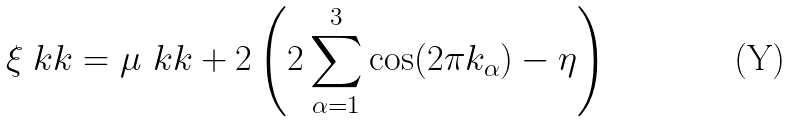Convert formula to latex. <formula><loc_0><loc_0><loc_500><loc_500>\xi _ { \ } k k = \mu _ { \ } k k + 2 \left ( 2 \sum _ { \alpha = 1 } ^ { 3 } \cos ( 2 \pi k _ { \alpha } ) - \eta \right )</formula> 